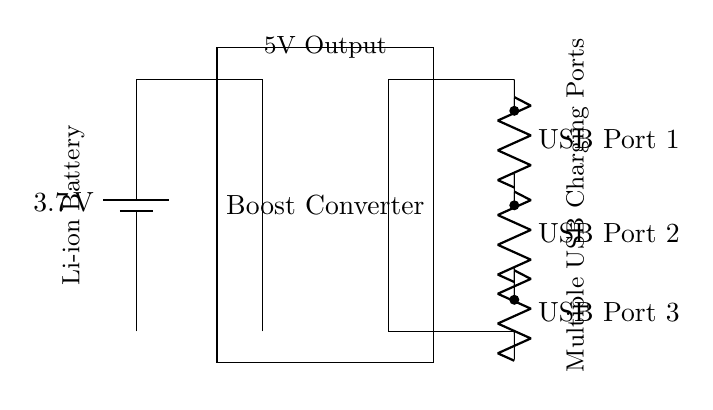What is the voltage of the battery? The diagram shows a lithium-ion battery rated at 3.7 volts. This is indicated directly on the battery symbol in the circuit.
Answer: 3.7 volts How many USB ports are in this circuit? By counting the connections labeled as USB ports in the circuit diagram, we find three USB ports. Each is indicated by a resistor symbol labeled sequentially from one to three.
Answer: Three What component converts voltage in this circuit? The boost converter is responsible for increasing the voltage from the battery to a higher level suitable for USB charging. It is indicated by a labeled box in the circuit.
Answer: Boost converter What is the output voltage of this circuit? The output voltage is 5 volts, as indicated by the label placed above the output line in the circuit diagram. This shows the result after the boost converter processes the input voltage from the battery.
Answer: 5 volts Describe the type of circuit represented. This is a parallel circuit setup because the USB ports are connected in parallel to the output of the boost converter, allowing simultaneous charging without affecting the voltage across each port.
Answer: Parallel circuit 